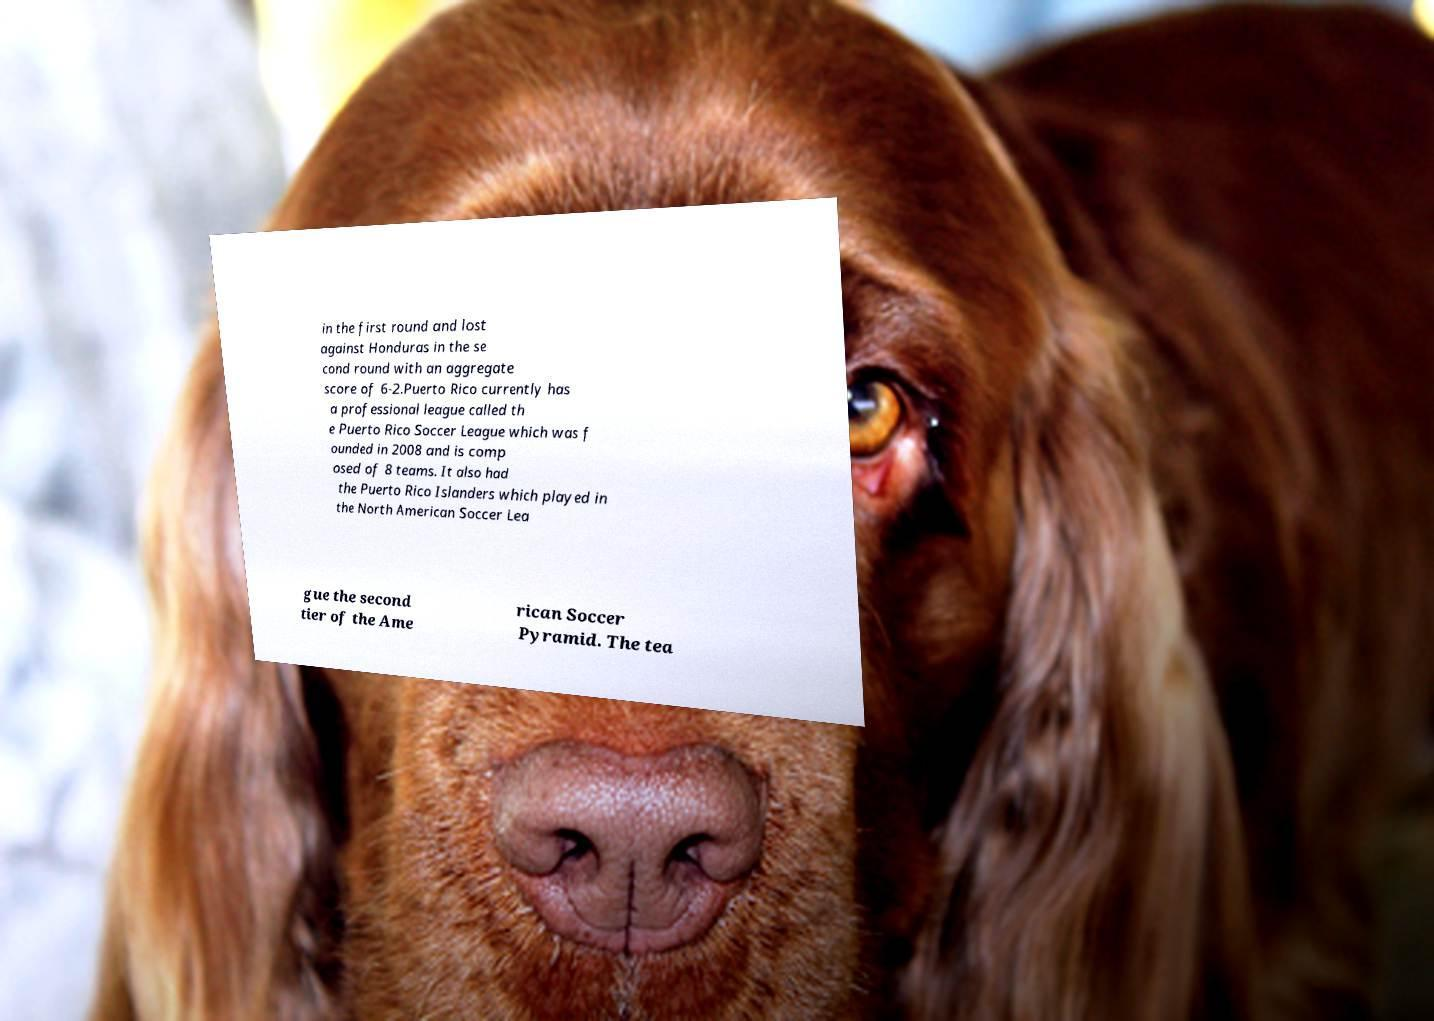Can you accurately transcribe the text from the provided image for me? in the first round and lost against Honduras in the se cond round with an aggregate score of 6-2.Puerto Rico currently has a professional league called th e Puerto Rico Soccer League which was f ounded in 2008 and is comp osed of 8 teams. It also had the Puerto Rico Islanders which played in the North American Soccer Lea gue the second tier of the Ame rican Soccer Pyramid. The tea 